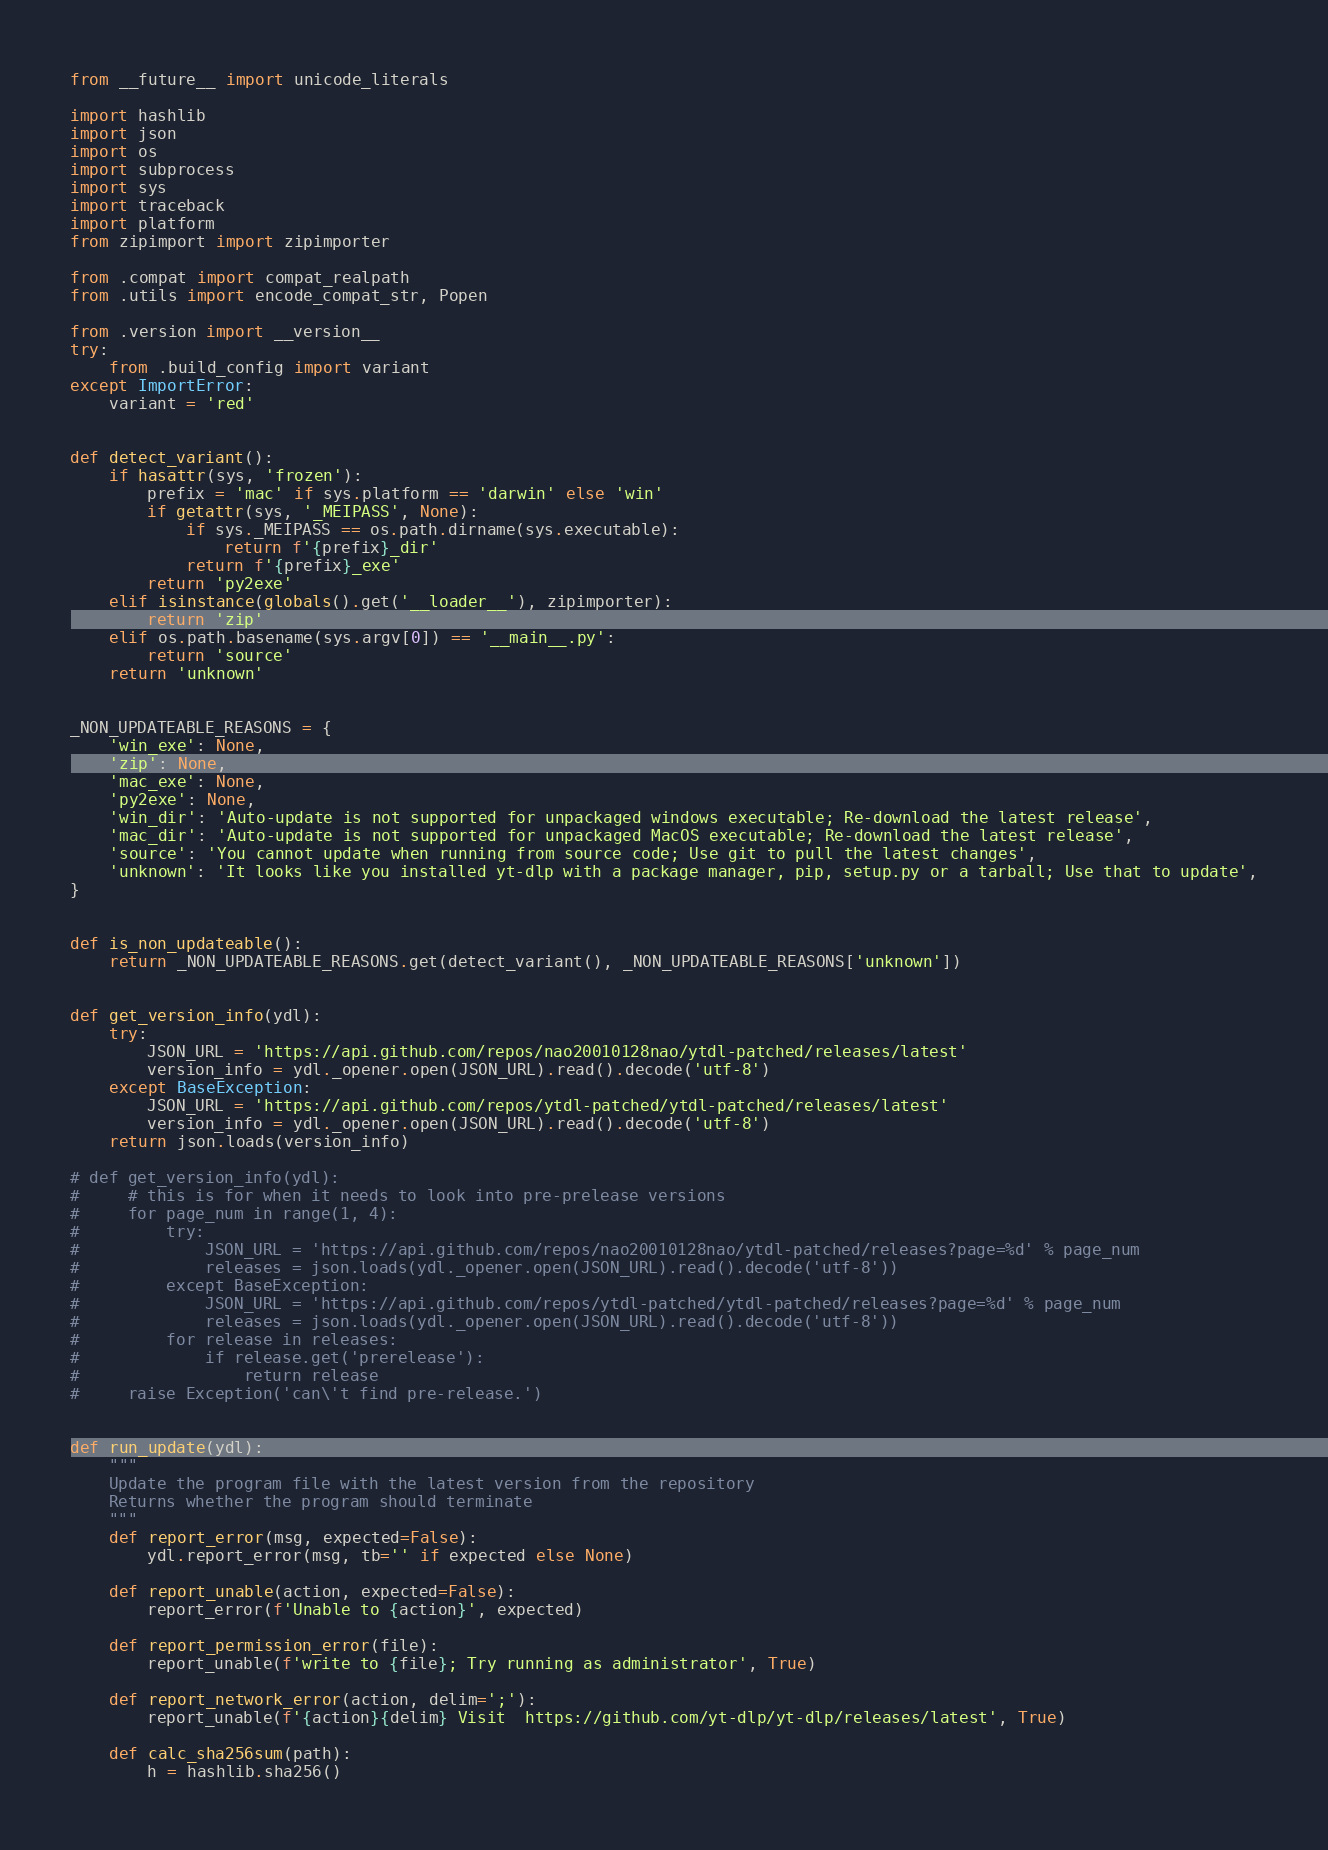Convert code to text. <code><loc_0><loc_0><loc_500><loc_500><_Python_>from __future__ import unicode_literals

import hashlib
import json
import os
import subprocess
import sys
import traceback
import platform
from zipimport import zipimporter

from .compat import compat_realpath
from .utils import encode_compat_str, Popen

from .version import __version__
try:
    from .build_config import variant
except ImportError:
    variant = 'red'


def detect_variant():
    if hasattr(sys, 'frozen'):
        prefix = 'mac' if sys.platform == 'darwin' else 'win'
        if getattr(sys, '_MEIPASS', None):
            if sys._MEIPASS == os.path.dirname(sys.executable):
                return f'{prefix}_dir'
            return f'{prefix}_exe'
        return 'py2exe'
    elif isinstance(globals().get('__loader__'), zipimporter):
        return 'zip'
    elif os.path.basename(sys.argv[0]) == '__main__.py':
        return 'source'
    return 'unknown'


_NON_UPDATEABLE_REASONS = {
    'win_exe': None,
    'zip': None,
    'mac_exe': None,
    'py2exe': None,
    'win_dir': 'Auto-update is not supported for unpackaged windows executable; Re-download the latest release',
    'mac_dir': 'Auto-update is not supported for unpackaged MacOS executable; Re-download the latest release',
    'source': 'You cannot update when running from source code; Use git to pull the latest changes',
    'unknown': 'It looks like you installed yt-dlp with a package manager, pip, setup.py or a tarball; Use that to update',
}


def is_non_updateable():
    return _NON_UPDATEABLE_REASONS.get(detect_variant(), _NON_UPDATEABLE_REASONS['unknown'])


def get_version_info(ydl):
    try:
        JSON_URL = 'https://api.github.com/repos/nao20010128nao/ytdl-patched/releases/latest'
        version_info = ydl._opener.open(JSON_URL).read().decode('utf-8')
    except BaseException:
        JSON_URL = 'https://api.github.com/repos/ytdl-patched/ytdl-patched/releases/latest'
        version_info = ydl._opener.open(JSON_URL).read().decode('utf-8')
    return json.loads(version_info)

# def get_version_info(ydl):
#     # this is for when it needs to look into pre-prelease versions
#     for page_num in range(1, 4):
#         try:
#             JSON_URL = 'https://api.github.com/repos/nao20010128nao/ytdl-patched/releases?page=%d' % page_num
#             releases = json.loads(ydl._opener.open(JSON_URL).read().decode('utf-8'))
#         except BaseException:
#             JSON_URL = 'https://api.github.com/repos/ytdl-patched/ytdl-patched/releases?page=%d' % page_num
#             releases = json.loads(ydl._opener.open(JSON_URL).read().decode('utf-8'))
#         for release in releases:
#             if release.get('prerelease'):
#                 return release
#     raise Exception('can\'t find pre-release.')


def run_update(ydl):
    """
    Update the program file with the latest version from the repository
    Returns whether the program should terminate
    """
    def report_error(msg, expected=False):
        ydl.report_error(msg, tb='' if expected else None)

    def report_unable(action, expected=False):
        report_error(f'Unable to {action}', expected)

    def report_permission_error(file):
        report_unable(f'write to {file}; Try running as administrator', True)

    def report_network_error(action, delim=';'):
        report_unable(f'{action}{delim} Visit  https://github.com/yt-dlp/yt-dlp/releases/latest', True)

    def calc_sha256sum(path):
        h = hashlib.sha256()</code> 